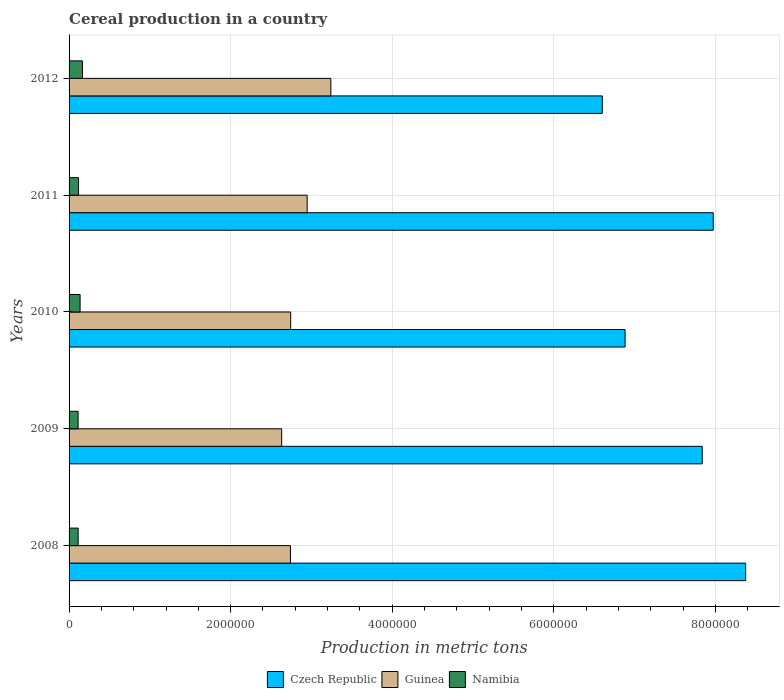How many groups of bars are there?
Provide a short and direct response. 5. Are the number of bars per tick equal to the number of legend labels?
Your answer should be compact. Yes. How many bars are there on the 1st tick from the bottom?
Your answer should be very brief. 3. What is the label of the 4th group of bars from the top?
Your response must be concise. 2009. In how many cases, is the number of bars for a given year not equal to the number of legend labels?
Offer a terse response. 0. What is the total cereal production in Czech Republic in 2012?
Give a very brief answer. 6.60e+06. Across all years, what is the maximum total cereal production in Namibia?
Your answer should be compact. 1.66e+05. Across all years, what is the minimum total cereal production in Guinea?
Provide a short and direct response. 2.63e+06. In which year was the total cereal production in Namibia maximum?
Keep it short and to the point. 2012. In which year was the total cereal production in Czech Republic minimum?
Make the answer very short. 2012. What is the total total cereal production in Namibia in the graph?
Provide a short and direct response. 6.44e+05. What is the difference between the total cereal production in Guinea in 2009 and that in 2012?
Provide a succinct answer. -6.09e+05. What is the difference between the total cereal production in Namibia in 2010 and the total cereal production in Guinea in 2009?
Give a very brief answer. -2.49e+06. What is the average total cereal production in Czech Republic per year?
Your response must be concise. 7.53e+06. In the year 2012, what is the difference between the total cereal production in Guinea and total cereal production in Namibia?
Your answer should be compact. 3.07e+06. What is the ratio of the total cereal production in Namibia in 2011 to that in 2012?
Offer a terse response. 0.71. Is the total cereal production in Guinea in 2009 less than that in 2010?
Your answer should be very brief. Yes. What is the difference between the highest and the second highest total cereal production in Czech Republic?
Offer a very short reply. 4.01e+05. What is the difference between the highest and the lowest total cereal production in Guinea?
Keep it short and to the point. 6.09e+05. In how many years, is the total cereal production in Czech Republic greater than the average total cereal production in Czech Republic taken over all years?
Make the answer very short. 3. Is the sum of the total cereal production in Guinea in 2009 and 2011 greater than the maximum total cereal production in Czech Republic across all years?
Ensure brevity in your answer.  No. What does the 3rd bar from the top in 2011 represents?
Offer a terse response. Czech Republic. What does the 2nd bar from the bottom in 2009 represents?
Your response must be concise. Guinea. Is it the case that in every year, the sum of the total cereal production in Czech Republic and total cereal production in Guinea is greater than the total cereal production in Namibia?
Offer a very short reply. Yes. What is the difference between two consecutive major ticks on the X-axis?
Offer a very short reply. 2.00e+06. Are the values on the major ticks of X-axis written in scientific E-notation?
Your answer should be very brief. No. Does the graph contain grids?
Keep it short and to the point. Yes. How many legend labels are there?
Your response must be concise. 3. What is the title of the graph?
Give a very brief answer. Cereal production in a country. Does "Central African Republic" appear as one of the legend labels in the graph?
Your answer should be compact. No. What is the label or title of the X-axis?
Offer a terse response. Production in metric tons. What is the Production in metric tons of Czech Republic in 2008?
Your answer should be compact. 8.37e+06. What is the Production in metric tons in Guinea in 2008?
Your answer should be compact. 2.74e+06. What is the Production in metric tons in Namibia in 2008?
Make the answer very short. 1.13e+05. What is the Production in metric tons in Czech Republic in 2009?
Your response must be concise. 7.84e+06. What is the Production in metric tons in Guinea in 2009?
Provide a succinct answer. 2.63e+06. What is the Production in metric tons of Namibia in 2009?
Provide a short and direct response. 1.12e+05. What is the Production in metric tons in Czech Republic in 2010?
Your response must be concise. 6.88e+06. What is the Production in metric tons of Guinea in 2010?
Ensure brevity in your answer.  2.74e+06. What is the Production in metric tons in Namibia in 2010?
Provide a succinct answer. 1.36e+05. What is the Production in metric tons in Czech Republic in 2011?
Your answer should be compact. 7.97e+06. What is the Production in metric tons of Guinea in 2011?
Keep it short and to the point. 2.95e+06. What is the Production in metric tons in Namibia in 2011?
Give a very brief answer. 1.17e+05. What is the Production in metric tons of Czech Republic in 2012?
Ensure brevity in your answer.  6.60e+06. What is the Production in metric tons in Guinea in 2012?
Offer a very short reply. 3.24e+06. What is the Production in metric tons of Namibia in 2012?
Ensure brevity in your answer.  1.66e+05. Across all years, what is the maximum Production in metric tons in Czech Republic?
Provide a succinct answer. 8.37e+06. Across all years, what is the maximum Production in metric tons in Guinea?
Give a very brief answer. 3.24e+06. Across all years, what is the maximum Production in metric tons in Namibia?
Your response must be concise. 1.66e+05. Across all years, what is the minimum Production in metric tons of Czech Republic?
Provide a succinct answer. 6.60e+06. Across all years, what is the minimum Production in metric tons of Guinea?
Offer a terse response. 2.63e+06. Across all years, what is the minimum Production in metric tons in Namibia?
Offer a terse response. 1.12e+05. What is the total Production in metric tons in Czech Republic in the graph?
Your answer should be compact. 3.77e+07. What is the total Production in metric tons in Guinea in the graph?
Your response must be concise. 1.43e+07. What is the total Production in metric tons of Namibia in the graph?
Provide a succinct answer. 6.44e+05. What is the difference between the Production in metric tons of Czech Republic in 2008 and that in 2009?
Your answer should be very brief. 5.38e+05. What is the difference between the Production in metric tons of Guinea in 2008 and that in 2009?
Keep it short and to the point. 1.09e+05. What is the difference between the Production in metric tons in Namibia in 2008 and that in 2009?
Provide a short and direct response. 842. What is the difference between the Production in metric tons in Czech Republic in 2008 and that in 2010?
Make the answer very short. 1.49e+06. What is the difference between the Production in metric tons of Guinea in 2008 and that in 2010?
Provide a short and direct response. -2689. What is the difference between the Production in metric tons in Namibia in 2008 and that in 2010?
Keep it short and to the point. -2.39e+04. What is the difference between the Production in metric tons of Czech Republic in 2008 and that in 2011?
Offer a terse response. 4.01e+05. What is the difference between the Production in metric tons of Guinea in 2008 and that in 2011?
Ensure brevity in your answer.  -2.07e+05. What is the difference between the Production in metric tons in Namibia in 2008 and that in 2011?
Give a very brief answer. -4420. What is the difference between the Production in metric tons in Czech Republic in 2008 and that in 2012?
Your answer should be compact. 1.77e+06. What is the difference between the Production in metric tons of Guinea in 2008 and that in 2012?
Your answer should be very brief. -5.00e+05. What is the difference between the Production in metric tons of Namibia in 2008 and that in 2012?
Your answer should be compact. -5.32e+04. What is the difference between the Production in metric tons in Czech Republic in 2009 and that in 2010?
Your response must be concise. 9.55e+05. What is the difference between the Production in metric tons of Guinea in 2009 and that in 2010?
Offer a terse response. -1.12e+05. What is the difference between the Production in metric tons in Namibia in 2009 and that in 2010?
Give a very brief answer. -2.48e+04. What is the difference between the Production in metric tons of Czech Republic in 2009 and that in 2011?
Provide a short and direct response. -1.37e+05. What is the difference between the Production in metric tons of Guinea in 2009 and that in 2011?
Make the answer very short. -3.16e+05. What is the difference between the Production in metric tons of Namibia in 2009 and that in 2011?
Provide a succinct answer. -5262. What is the difference between the Production in metric tons in Czech Republic in 2009 and that in 2012?
Make the answer very short. 1.24e+06. What is the difference between the Production in metric tons of Guinea in 2009 and that in 2012?
Keep it short and to the point. -6.09e+05. What is the difference between the Production in metric tons of Namibia in 2009 and that in 2012?
Your answer should be very brief. -5.41e+04. What is the difference between the Production in metric tons of Czech Republic in 2010 and that in 2011?
Your answer should be very brief. -1.09e+06. What is the difference between the Production in metric tons in Guinea in 2010 and that in 2011?
Make the answer very short. -2.04e+05. What is the difference between the Production in metric tons of Namibia in 2010 and that in 2011?
Make the answer very short. 1.95e+04. What is the difference between the Production in metric tons of Czech Republic in 2010 and that in 2012?
Give a very brief answer. 2.82e+05. What is the difference between the Production in metric tons in Guinea in 2010 and that in 2012?
Keep it short and to the point. -4.97e+05. What is the difference between the Production in metric tons of Namibia in 2010 and that in 2012?
Make the answer very short. -2.93e+04. What is the difference between the Production in metric tons of Czech Republic in 2011 and that in 2012?
Your answer should be very brief. 1.37e+06. What is the difference between the Production in metric tons in Guinea in 2011 and that in 2012?
Offer a very short reply. -2.93e+05. What is the difference between the Production in metric tons in Namibia in 2011 and that in 2012?
Offer a very short reply. -4.88e+04. What is the difference between the Production in metric tons of Czech Republic in 2008 and the Production in metric tons of Guinea in 2009?
Keep it short and to the point. 5.74e+06. What is the difference between the Production in metric tons of Czech Republic in 2008 and the Production in metric tons of Namibia in 2009?
Ensure brevity in your answer.  8.26e+06. What is the difference between the Production in metric tons of Guinea in 2008 and the Production in metric tons of Namibia in 2009?
Ensure brevity in your answer.  2.63e+06. What is the difference between the Production in metric tons in Czech Republic in 2008 and the Production in metric tons in Guinea in 2010?
Offer a very short reply. 5.63e+06. What is the difference between the Production in metric tons of Czech Republic in 2008 and the Production in metric tons of Namibia in 2010?
Make the answer very short. 8.24e+06. What is the difference between the Production in metric tons of Guinea in 2008 and the Production in metric tons of Namibia in 2010?
Keep it short and to the point. 2.60e+06. What is the difference between the Production in metric tons in Czech Republic in 2008 and the Production in metric tons in Guinea in 2011?
Your answer should be compact. 5.43e+06. What is the difference between the Production in metric tons in Czech Republic in 2008 and the Production in metric tons in Namibia in 2011?
Provide a short and direct response. 8.26e+06. What is the difference between the Production in metric tons in Guinea in 2008 and the Production in metric tons in Namibia in 2011?
Offer a very short reply. 2.62e+06. What is the difference between the Production in metric tons of Czech Republic in 2008 and the Production in metric tons of Guinea in 2012?
Your answer should be very brief. 5.13e+06. What is the difference between the Production in metric tons in Czech Republic in 2008 and the Production in metric tons in Namibia in 2012?
Offer a terse response. 8.21e+06. What is the difference between the Production in metric tons in Guinea in 2008 and the Production in metric tons in Namibia in 2012?
Provide a short and direct response. 2.57e+06. What is the difference between the Production in metric tons in Czech Republic in 2009 and the Production in metric tons in Guinea in 2010?
Offer a terse response. 5.09e+06. What is the difference between the Production in metric tons in Czech Republic in 2009 and the Production in metric tons in Namibia in 2010?
Give a very brief answer. 7.70e+06. What is the difference between the Production in metric tons in Guinea in 2009 and the Production in metric tons in Namibia in 2010?
Your answer should be compact. 2.49e+06. What is the difference between the Production in metric tons of Czech Republic in 2009 and the Production in metric tons of Guinea in 2011?
Keep it short and to the point. 4.89e+06. What is the difference between the Production in metric tons in Czech Republic in 2009 and the Production in metric tons in Namibia in 2011?
Offer a very short reply. 7.72e+06. What is the difference between the Production in metric tons in Guinea in 2009 and the Production in metric tons in Namibia in 2011?
Offer a very short reply. 2.51e+06. What is the difference between the Production in metric tons of Czech Republic in 2009 and the Production in metric tons of Guinea in 2012?
Give a very brief answer. 4.60e+06. What is the difference between the Production in metric tons of Czech Republic in 2009 and the Production in metric tons of Namibia in 2012?
Make the answer very short. 7.67e+06. What is the difference between the Production in metric tons of Guinea in 2009 and the Production in metric tons of Namibia in 2012?
Offer a terse response. 2.47e+06. What is the difference between the Production in metric tons in Czech Republic in 2010 and the Production in metric tons in Guinea in 2011?
Your answer should be compact. 3.93e+06. What is the difference between the Production in metric tons of Czech Republic in 2010 and the Production in metric tons of Namibia in 2011?
Ensure brevity in your answer.  6.76e+06. What is the difference between the Production in metric tons of Guinea in 2010 and the Production in metric tons of Namibia in 2011?
Offer a terse response. 2.63e+06. What is the difference between the Production in metric tons in Czech Republic in 2010 and the Production in metric tons in Guinea in 2012?
Offer a very short reply. 3.64e+06. What is the difference between the Production in metric tons of Czech Republic in 2010 and the Production in metric tons of Namibia in 2012?
Keep it short and to the point. 6.72e+06. What is the difference between the Production in metric tons of Guinea in 2010 and the Production in metric tons of Namibia in 2012?
Your response must be concise. 2.58e+06. What is the difference between the Production in metric tons of Czech Republic in 2011 and the Production in metric tons of Guinea in 2012?
Ensure brevity in your answer.  4.73e+06. What is the difference between the Production in metric tons in Czech Republic in 2011 and the Production in metric tons in Namibia in 2012?
Give a very brief answer. 7.81e+06. What is the difference between the Production in metric tons in Guinea in 2011 and the Production in metric tons in Namibia in 2012?
Provide a succinct answer. 2.78e+06. What is the average Production in metric tons of Czech Republic per year?
Keep it short and to the point. 7.53e+06. What is the average Production in metric tons in Guinea per year?
Your answer should be compact. 2.86e+06. What is the average Production in metric tons in Namibia per year?
Provide a short and direct response. 1.29e+05. In the year 2008, what is the difference between the Production in metric tons of Czech Republic and Production in metric tons of Guinea?
Offer a very short reply. 5.63e+06. In the year 2008, what is the difference between the Production in metric tons of Czech Republic and Production in metric tons of Namibia?
Ensure brevity in your answer.  8.26e+06. In the year 2008, what is the difference between the Production in metric tons of Guinea and Production in metric tons of Namibia?
Offer a terse response. 2.63e+06. In the year 2009, what is the difference between the Production in metric tons of Czech Republic and Production in metric tons of Guinea?
Your response must be concise. 5.21e+06. In the year 2009, what is the difference between the Production in metric tons of Czech Republic and Production in metric tons of Namibia?
Your response must be concise. 7.72e+06. In the year 2009, what is the difference between the Production in metric tons in Guinea and Production in metric tons in Namibia?
Provide a short and direct response. 2.52e+06. In the year 2010, what is the difference between the Production in metric tons in Czech Republic and Production in metric tons in Guinea?
Offer a terse response. 4.14e+06. In the year 2010, what is the difference between the Production in metric tons of Czech Republic and Production in metric tons of Namibia?
Your response must be concise. 6.75e+06. In the year 2010, what is the difference between the Production in metric tons of Guinea and Production in metric tons of Namibia?
Keep it short and to the point. 2.61e+06. In the year 2011, what is the difference between the Production in metric tons in Czech Republic and Production in metric tons in Guinea?
Offer a terse response. 5.03e+06. In the year 2011, what is the difference between the Production in metric tons of Czech Republic and Production in metric tons of Namibia?
Provide a short and direct response. 7.86e+06. In the year 2011, what is the difference between the Production in metric tons in Guinea and Production in metric tons in Namibia?
Your answer should be compact. 2.83e+06. In the year 2012, what is the difference between the Production in metric tons of Czech Republic and Production in metric tons of Guinea?
Your answer should be compact. 3.36e+06. In the year 2012, what is the difference between the Production in metric tons of Czech Republic and Production in metric tons of Namibia?
Offer a terse response. 6.43e+06. In the year 2012, what is the difference between the Production in metric tons in Guinea and Production in metric tons in Namibia?
Offer a very short reply. 3.07e+06. What is the ratio of the Production in metric tons in Czech Republic in 2008 to that in 2009?
Your answer should be compact. 1.07. What is the ratio of the Production in metric tons in Guinea in 2008 to that in 2009?
Make the answer very short. 1.04. What is the ratio of the Production in metric tons of Namibia in 2008 to that in 2009?
Offer a terse response. 1.01. What is the ratio of the Production in metric tons in Czech Republic in 2008 to that in 2010?
Give a very brief answer. 1.22. What is the ratio of the Production in metric tons in Guinea in 2008 to that in 2010?
Make the answer very short. 1. What is the ratio of the Production in metric tons in Namibia in 2008 to that in 2010?
Provide a short and direct response. 0.82. What is the ratio of the Production in metric tons in Czech Republic in 2008 to that in 2011?
Offer a very short reply. 1.05. What is the ratio of the Production in metric tons in Guinea in 2008 to that in 2011?
Your answer should be compact. 0.93. What is the ratio of the Production in metric tons of Namibia in 2008 to that in 2011?
Your response must be concise. 0.96. What is the ratio of the Production in metric tons of Czech Republic in 2008 to that in 2012?
Make the answer very short. 1.27. What is the ratio of the Production in metric tons of Guinea in 2008 to that in 2012?
Provide a succinct answer. 0.85. What is the ratio of the Production in metric tons in Namibia in 2008 to that in 2012?
Make the answer very short. 0.68. What is the ratio of the Production in metric tons of Czech Republic in 2009 to that in 2010?
Offer a terse response. 1.14. What is the ratio of the Production in metric tons of Guinea in 2009 to that in 2010?
Offer a very short reply. 0.96. What is the ratio of the Production in metric tons in Namibia in 2009 to that in 2010?
Your answer should be compact. 0.82. What is the ratio of the Production in metric tons in Czech Republic in 2009 to that in 2011?
Give a very brief answer. 0.98. What is the ratio of the Production in metric tons of Guinea in 2009 to that in 2011?
Your answer should be very brief. 0.89. What is the ratio of the Production in metric tons of Namibia in 2009 to that in 2011?
Keep it short and to the point. 0.95. What is the ratio of the Production in metric tons of Czech Republic in 2009 to that in 2012?
Your answer should be compact. 1.19. What is the ratio of the Production in metric tons in Guinea in 2009 to that in 2012?
Provide a short and direct response. 0.81. What is the ratio of the Production in metric tons in Namibia in 2009 to that in 2012?
Provide a succinct answer. 0.67. What is the ratio of the Production in metric tons of Czech Republic in 2010 to that in 2011?
Offer a terse response. 0.86. What is the ratio of the Production in metric tons of Guinea in 2010 to that in 2011?
Provide a succinct answer. 0.93. What is the ratio of the Production in metric tons of Czech Republic in 2010 to that in 2012?
Offer a very short reply. 1.04. What is the ratio of the Production in metric tons in Guinea in 2010 to that in 2012?
Your answer should be compact. 0.85. What is the ratio of the Production in metric tons of Namibia in 2010 to that in 2012?
Keep it short and to the point. 0.82. What is the ratio of the Production in metric tons of Czech Republic in 2011 to that in 2012?
Provide a short and direct response. 1.21. What is the ratio of the Production in metric tons in Guinea in 2011 to that in 2012?
Keep it short and to the point. 0.91. What is the ratio of the Production in metric tons of Namibia in 2011 to that in 2012?
Your answer should be very brief. 0.71. What is the difference between the highest and the second highest Production in metric tons of Czech Republic?
Offer a terse response. 4.01e+05. What is the difference between the highest and the second highest Production in metric tons of Guinea?
Offer a very short reply. 2.93e+05. What is the difference between the highest and the second highest Production in metric tons in Namibia?
Your answer should be very brief. 2.93e+04. What is the difference between the highest and the lowest Production in metric tons in Czech Republic?
Your answer should be very brief. 1.77e+06. What is the difference between the highest and the lowest Production in metric tons of Guinea?
Your answer should be very brief. 6.09e+05. What is the difference between the highest and the lowest Production in metric tons in Namibia?
Offer a very short reply. 5.41e+04. 